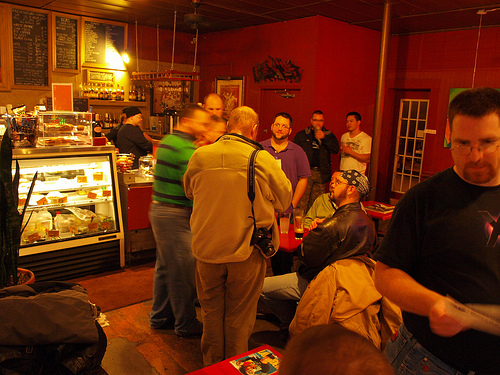<image>
Is there a camera under the jacket? Yes. The camera is positioned underneath the jacket, with the jacket above it in the vertical space. Where is the food in relation to the man? Is it behind the man? Yes. From this viewpoint, the food is positioned behind the man, with the man partially or fully occluding the food. Is there a table next to the man? Yes. The table is positioned adjacent to the man, located nearby in the same general area. 